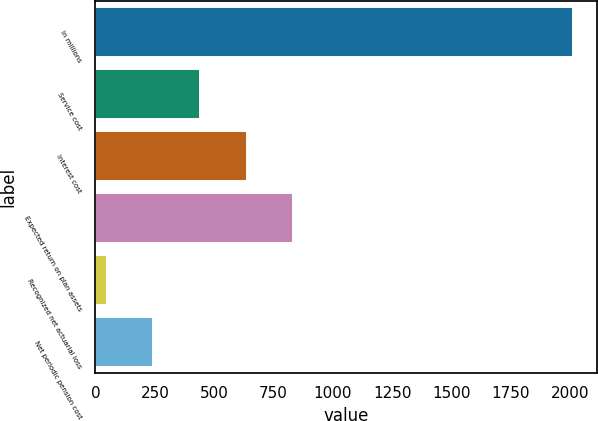<chart> <loc_0><loc_0><loc_500><loc_500><bar_chart><fcel>In millions<fcel>Service cost<fcel>Interest cost<fcel>Expected return on plan assets<fcel>Recognized net actuarial loss<fcel>Net periodic pension cost<nl><fcel>2012<fcel>440<fcel>636.5<fcel>833<fcel>47<fcel>243.5<nl></chart> 